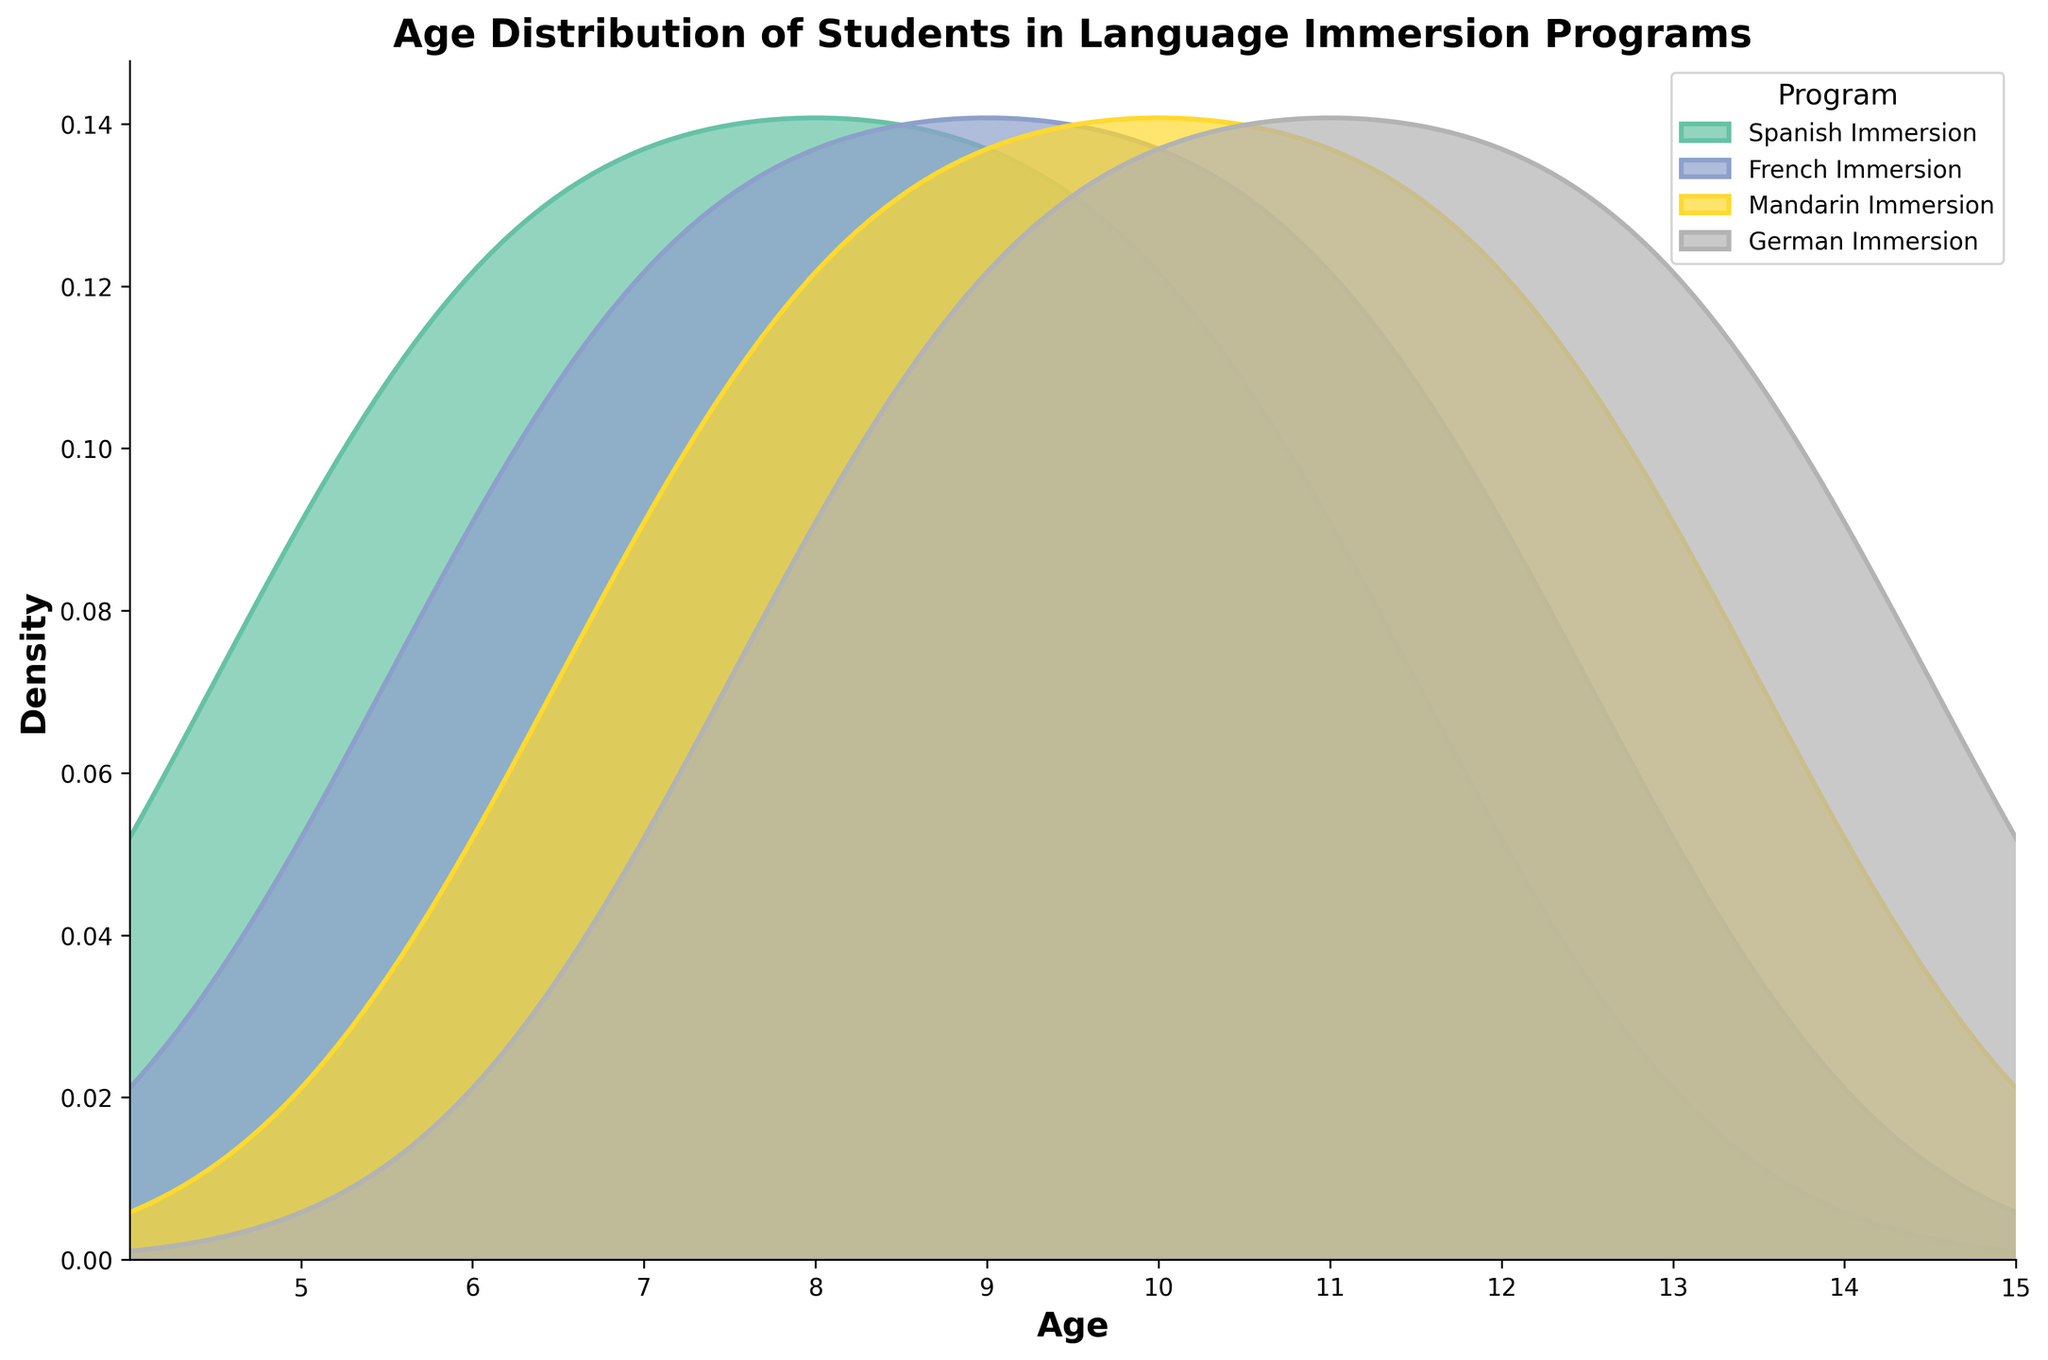What is the title of the plot? The title of the plot is located at the top of the figure and is usually formatted in a larger and bold font for prominence. In this case, it reads: "Age Distribution of Students in Language Immersion Programs."
Answer: Age Distribution of Students in Language Immersion Programs Which program has the highest density peak? To determine the highest density peak, we need to look at the curves and identify the one that reaches the highest point. The Mandarin Immersion program has the highest peak around the age of 11.
Answer: Mandarin Immersion At what age does the German Immersion program's density peak occur? Observe the curve labeled 'German Immersion' and find where it reaches its highest point along the age axis. The peak occurs at age 12.
Answer: 12 How many programs have a peak density at ages younger than 10? We need to examine each program's density curve to see if their highest points occur before age 10. Spanish Immersion has its peak around age 6, and French Immersion peaks around age 7.
Answer: 2 Which program shows the widest spread in student ages? By examining the spread of densities along the age axis for each program, the German Immersion program shows a wider spread, covering ages from 8 to 14.
Answer: German Immersion At what age does the French Immersion density peak? Locate the peak of the density curve labeled 'French Immersion.' The peak occurs around age 7.
Answer: 7 Between Spanish and Mandarin Immersion programs, which one has a peak density at a younger age? Compare the peaks of both the Spanish Immersion and Mandarin Immersion curves. The Spanish Immersion's peak is at age 6, while Mandarin Immersion peaks around age 11.
Answer: Spanish Immersion Which two programs have overlapping density curves between ages 10 and 12? Examine the density curves between ages 10 and 12 for all programs and identify which ones overlap. Both Mandarin Immersion and German Immersion have overlapping curves in this age range.
Answer: Mandarin Immersion and German Immersion At what age does the Mandarin Immersion density start to decline? Identify the downward slope of the Mandarin Immersion density curve after it peaks. The decline starts just after age 11.
Answer: After age 11 